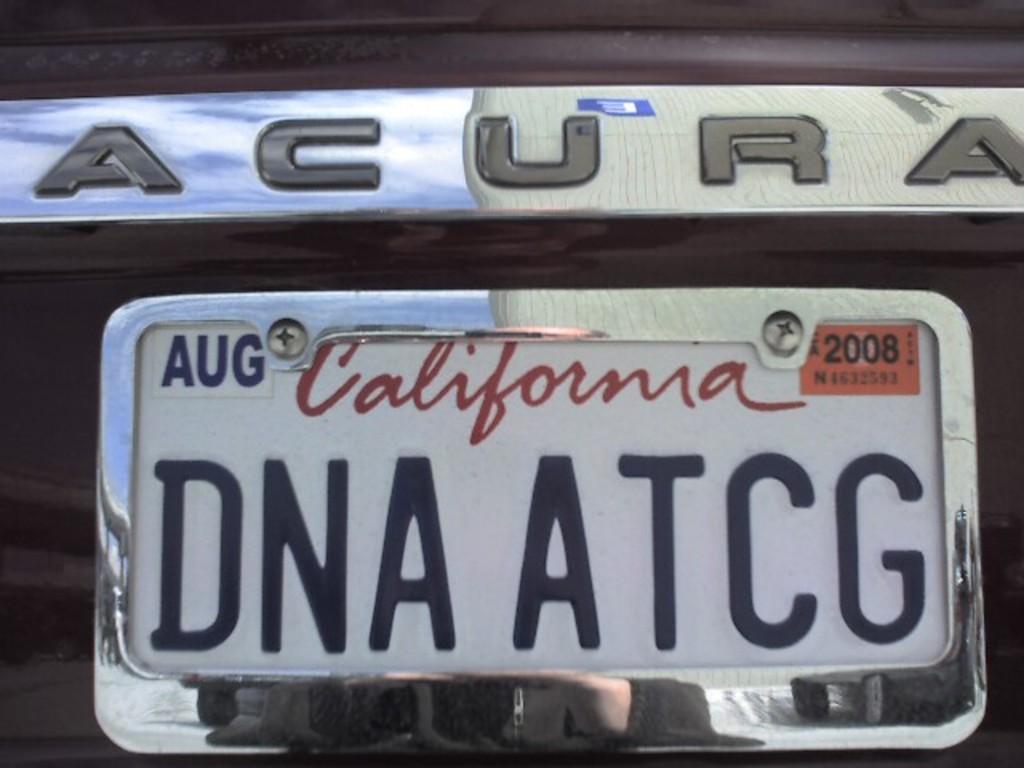What state does the license tag go to?
Your answer should be very brief. California. 